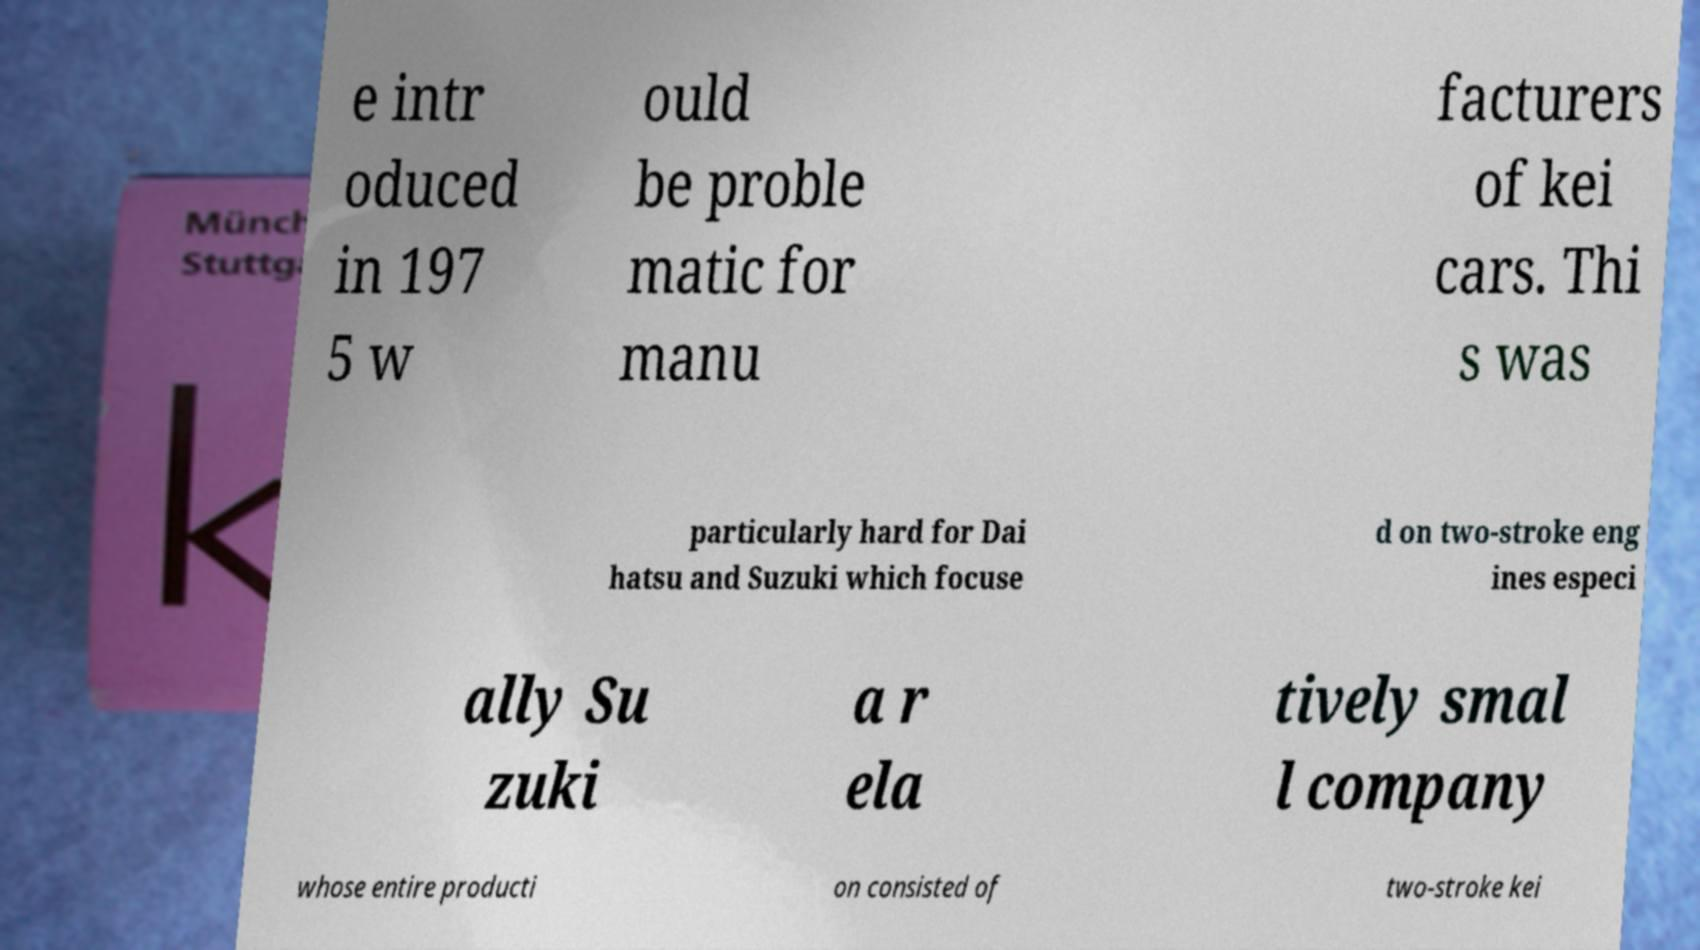Can you read and provide the text displayed in the image?This photo seems to have some interesting text. Can you extract and type it out for me? e intr oduced in 197 5 w ould be proble matic for manu facturers of kei cars. Thi s was particularly hard for Dai hatsu and Suzuki which focuse d on two-stroke eng ines especi ally Su zuki a r ela tively smal l company whose entire producti on consisted of two-stroke kei 